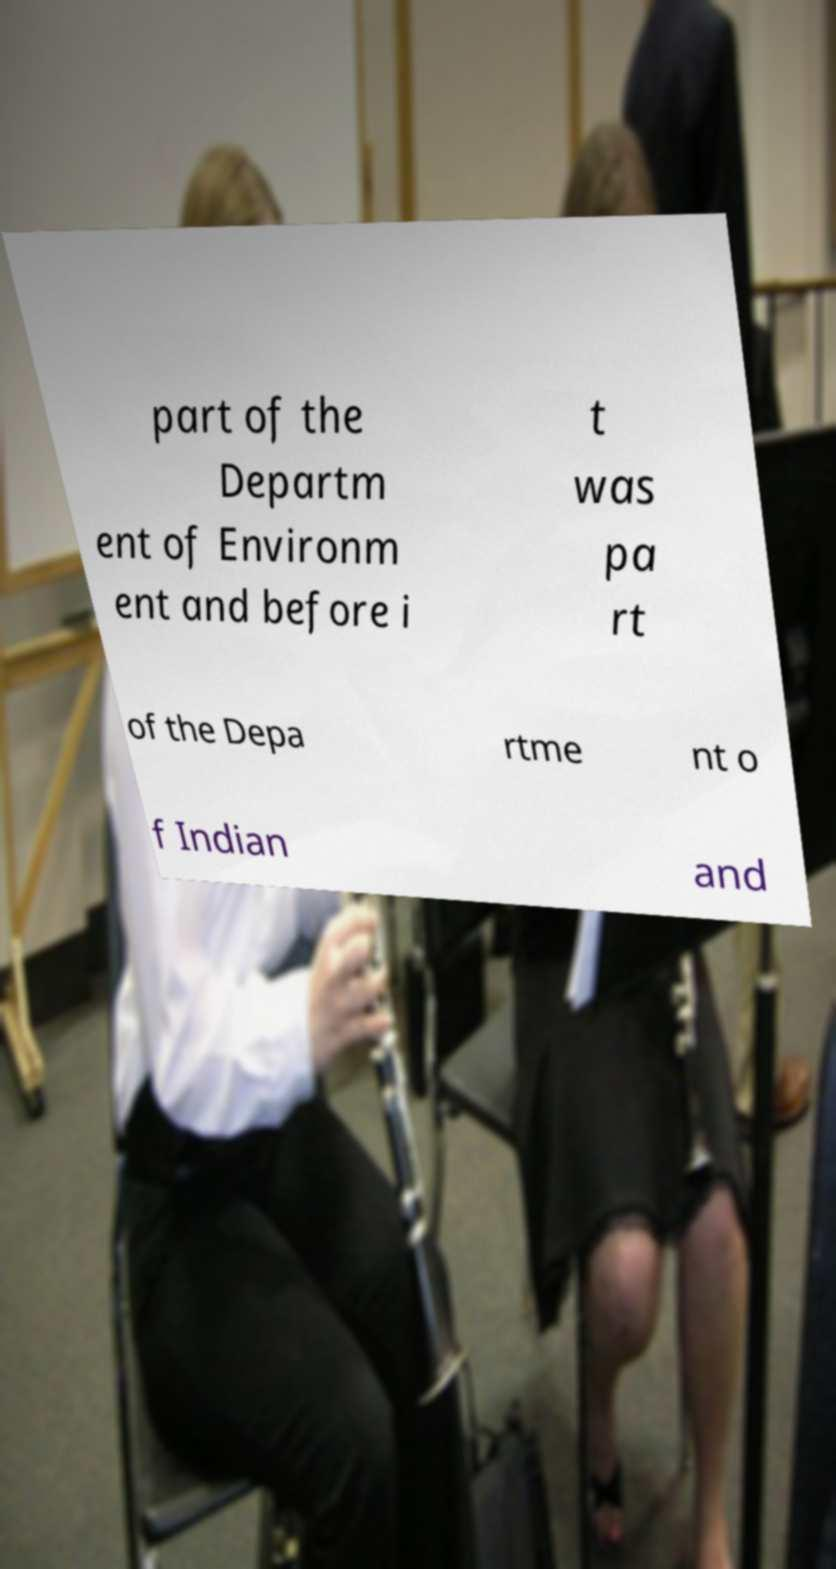Can you accurately transcribe the text from the provided image for me? part of the Departm ent of Environm ent and before i t was pa rt of the Depa rtme nt o f Indian and 